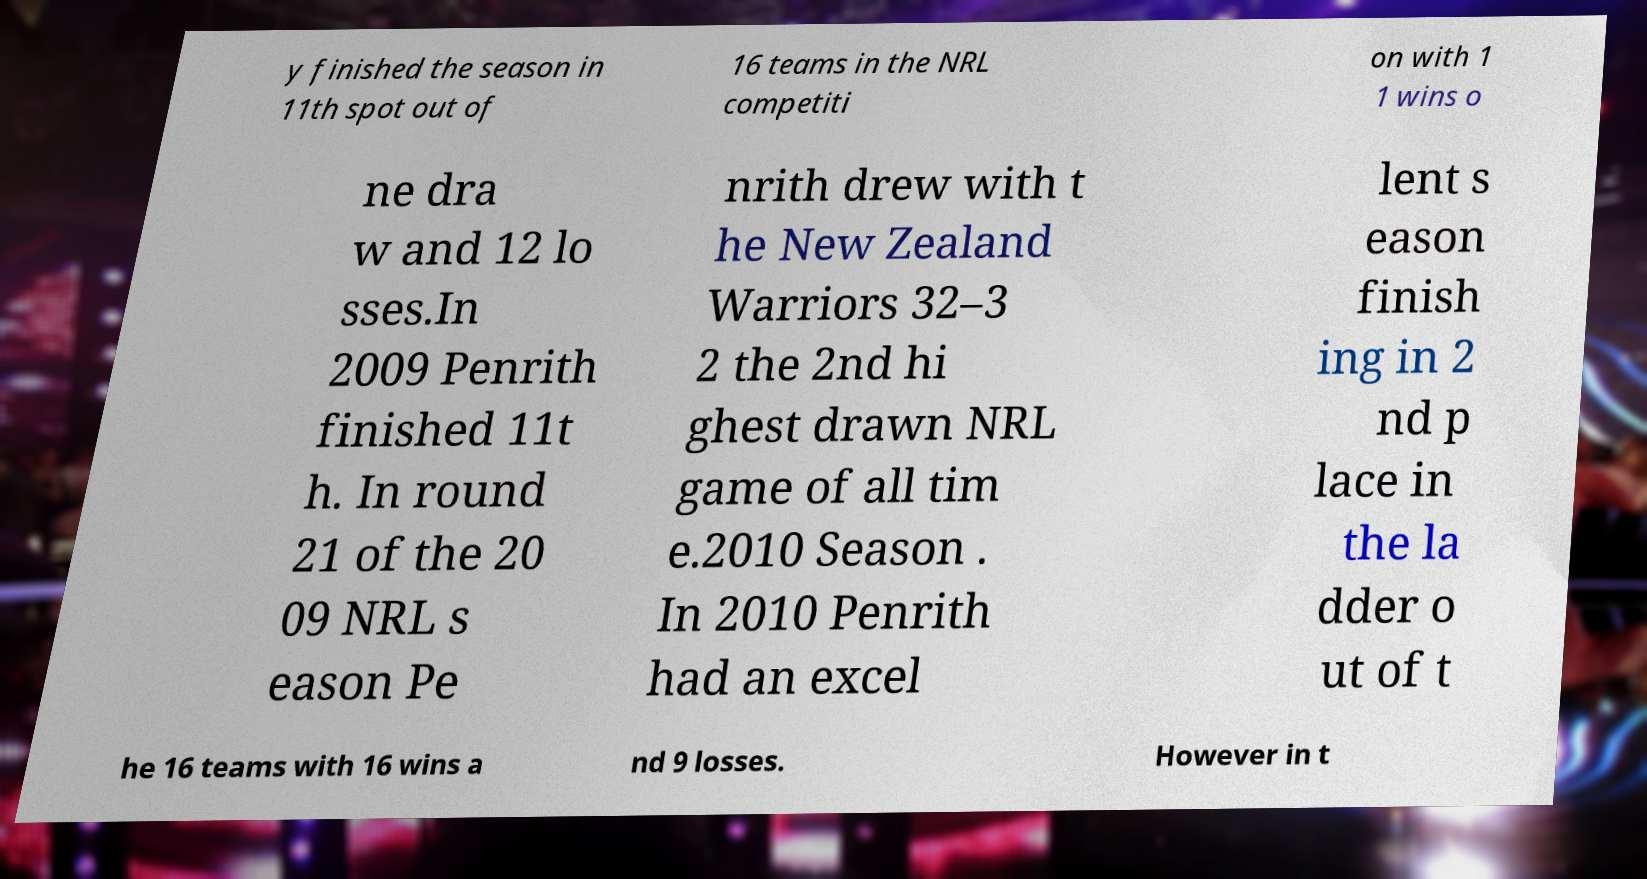Can you accurately transcribe the text from the provided image for me? y finished the season in 11th spot out of 16 teams in the NRL competiti on with 1 1 wins o ne dra w and 12 lo sses.In 2009 Penrith finished 11t h. In round 21 of the 20 09 NRL s eason Pe nrith drew with t he New Zealand Warriors 32–3 2 the 2nd hi ghest drawn NRL game of all tim e.2010 Season . In 2010 Penrith had an excel lent s eason finish ing in 2 nd p lace in the la dder o ut of t he 16 teams with 16 wins a nd 9 losses. However in t 